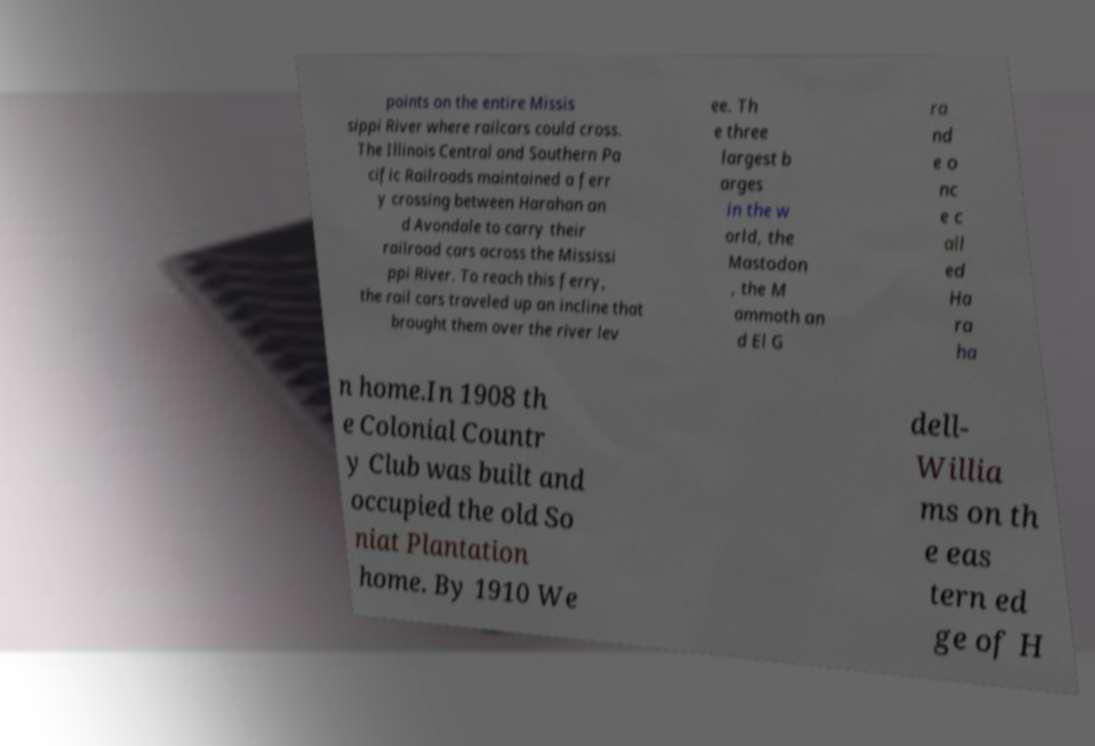Can you read and provide the text displayed in the image?This photo seems to have some interesting text. Can you extract and type it out for me? points on the entire Missis sippi River where railcars could cross. The Illinois Central and Southern Pa cific Railroads maintained a ferr y crossing between Harahan an d Avondale to carry their railroad cars across the Mississi ppi River. To reach this ferry, the rail cars traveled up an incline that brought them over the river lev ee. Th e three largest b arges in the w orld, the Mastodon , the M ammoth an d El G ra nd e o nc e c all ed Ha ra ha n home.In 1908 th e Colonial Countr y Club was built and occupied the old So niat Plantation home. By 1910 We dell- Willia ms on th e eas tern ed ge of H 